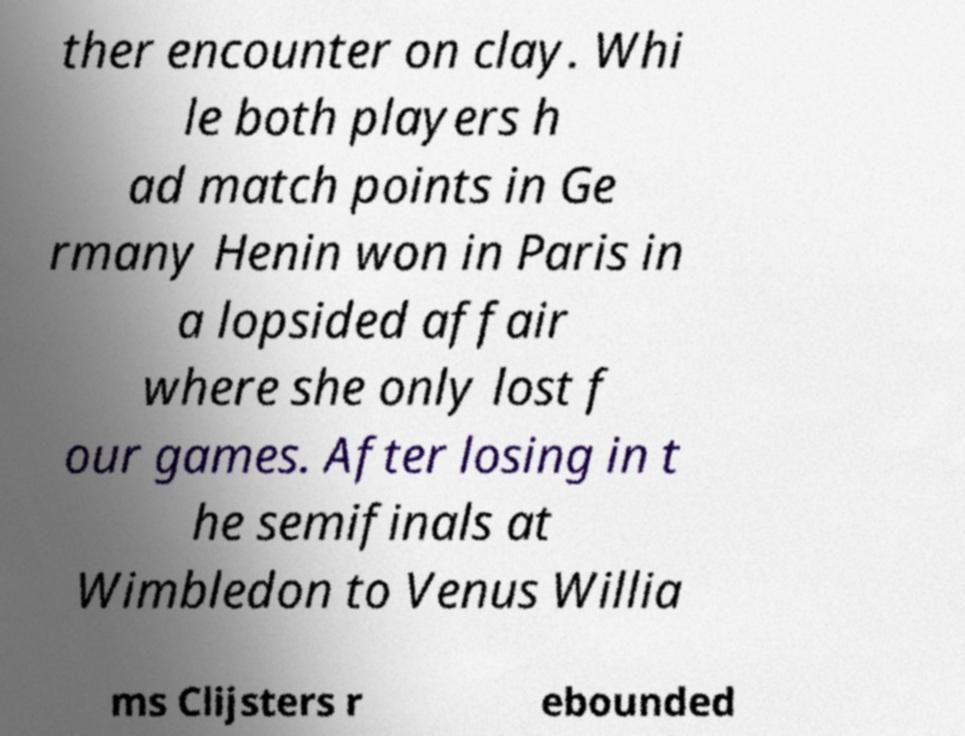There's text embedded in this image that I need extracted. Can you transcribe it verbatim? ther encounter on clay. Whi le both players h ad match points in Ge rmany Henin won in Paris in a lopsided affair where she only lost f our games. After losing in t he semifinals at Wimbledon to Venus Willia ms Clijsters r ebounded 